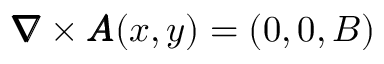<formula> <loc_0><loc_0><loc_500><loc_500>\pm b { \nabla } \times \pm b { A } ( x , y ) = ( 0 , 0 , B )</formula> 